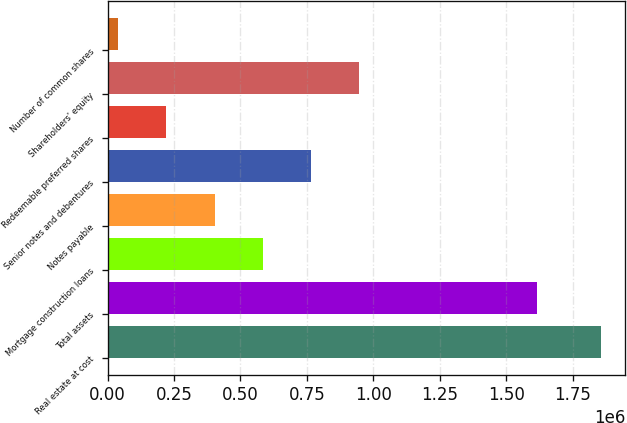Convert chart. <chart><loc_0><loc_0><loc_500><loc_500><bar_chart><fcel>Real estate at cost<fcel>Total assets<fcel>Mortgage construction loans<fcel>Notes payable<fcel>Senior notes and debentures<fcel>Redeemable preferred shares<fcel>Shareholders' equity<fcel>Number of common shares<nl><fcel>1.85491e+06<fcel>1.61696e+06<fcel>584102<fcel>402558<fcel>765647<fcel>221013<fcel>947191<fcel>39469<nl></chart> 